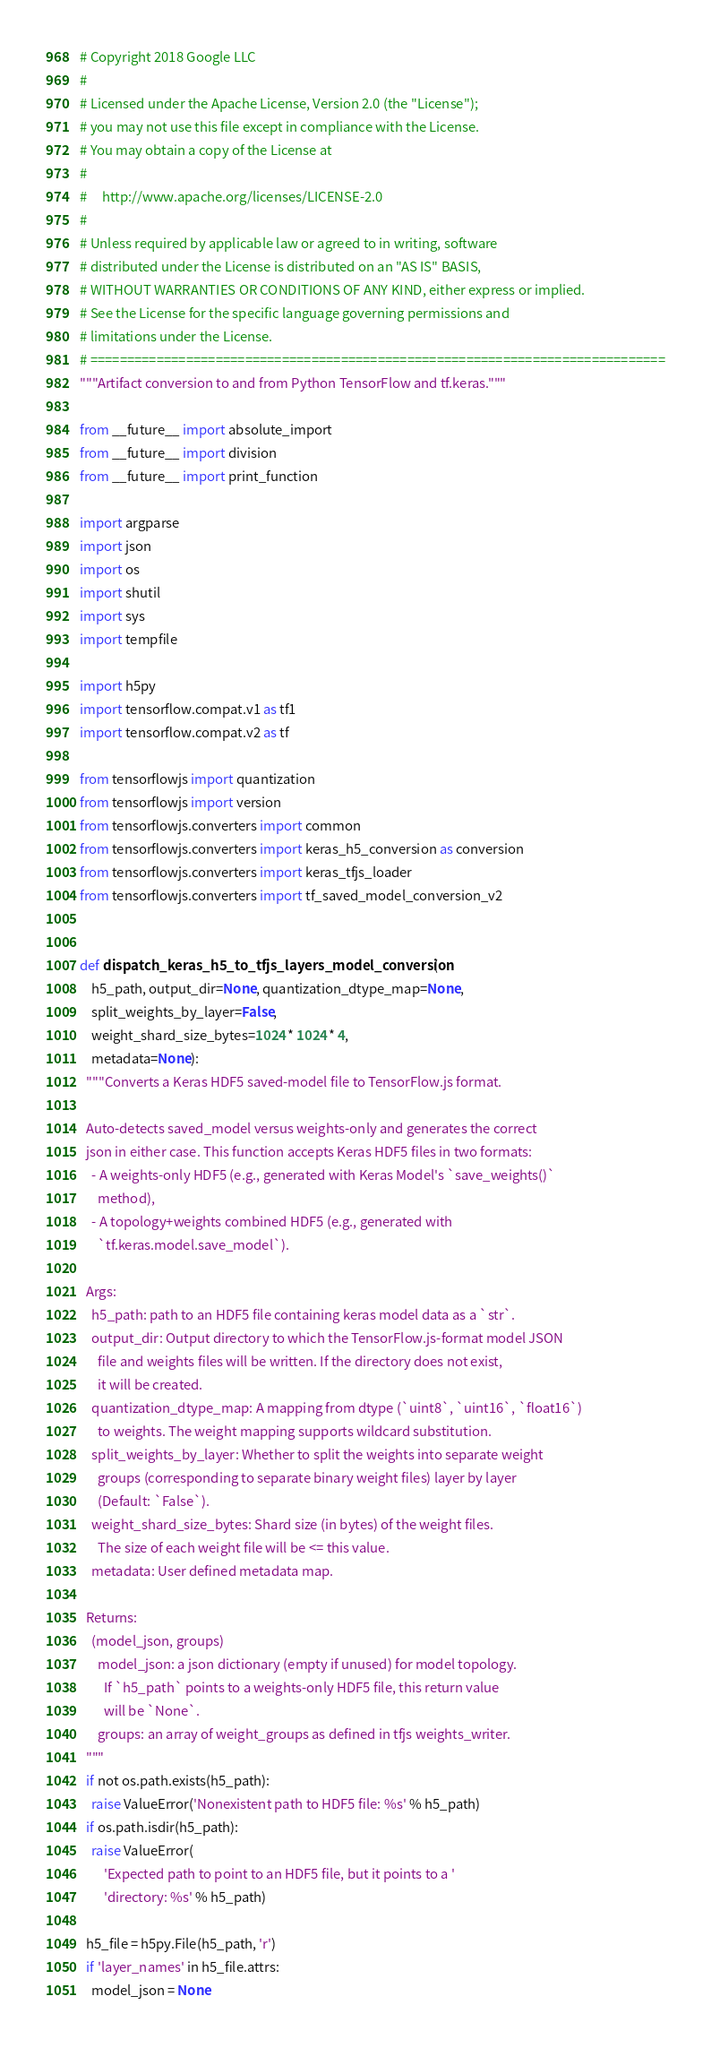<code> <loc_0><loc_0><loc_500><loc_500><_Python_># Copyright 2018 Google LLC
#
# Licensed under the Apache License, Version 2.0 (the "License");
# you may not use this file except in compliance with the License.
# You may obtain a copy of the License at
#
#     http://www.apache.org/licenses/LICENSE-2.0
#
# Unless required by applicable law or agreed to in writing, software
# distributed under the License is distributed on an "AS IS" BASIS,
# WITHOUT WARRANTIES OR CONDITIONS OF ANY KIND, either express or implied.
# See the License for the specific language governing permissions and
# limitations under the License.
# ==============================================================================
"""Artifact conversion to and from Python TensorFlow and tf.keras."""

from __future__ import absolute_import
from __future__ import division
from __future__ import print_function

import argparse
import json
import os
import shutil
import sys
import tempfile

import h5py
import tensorflow.compat.v1 as tf1
import tensorflow.compat.v2 as tf

from tensorflowjs import quantization
from tensorflowjs import version
from tensorflowjs.converters import common
from tensorflowjs.converters import keras_h5_conversion as conversion
from tensorflowjs.converters import keras_tfjs_loader
from tensorflowjs.converters import tf_saved_model_conversion_v2


def dispatch_keras_h5_to_tfjs_layers_model_conversion(
    h5_path, output_dir=None, quantization_dtype_map=None,
    split_weights_by_layer=False,
    weight_shard_size_bytes=1024 * 1024 * 4,
    metadata=None):
  """Converts a Keras HDF5 saved-model file to TensorFlow.js format.

  Auto-detects saved_model versus weights-only and generates the correct
  json in either case. This function accepts Keras HDF5 files in two formats:
    - A weights-only HDF5 (e.g., generated with Keras Model's `save_weights()`
      method),
    - A topology+weights combined HDF5 (e.g., generated with
      `tf.keras.model.save_model`).

  Args:
    h5_path: path to an HDF5 file containing keras model data as a `str`.
    output_dir: Output directory to which the TensorFlow.js-format model JSON
      file and weights files will be written. If the directory does not exist,
      it will be created.
    quantization_dtype_map: A mapping from dtype (`uint8`, `uint16`, `float16`)
      to weights. The weight mapping supports wildcard substitution.
    split_weights_by_layer: Whether to split the weights into separate weight
      groups (corresponding to separate binary weight files) layer by layer
      (Default: `False`).
    weight_shard_size_bytes: Shard size (in bytes) of the weight files.
      The size of each weight file will be <= this value.
    metadata: User defined metadata map.

  Returns:
    (model_json, groups)
      model_json: a json dictionary (empty if unused) for model topology.
        If `h5_path` points to a weights-only HDF5 file, this return value
        will be `None`.
      groups: an array of weight_groups as defined in tfjs weights_writer.
  """
  if not os.path.exists(h5_path):
    raise ValueError('Nonexistent path to HDF5 file: %s' % h5_path)
  if os.path.isdir(h5_path):
    raise ValueError(
        'Expected path to point to an HDF5 file, but it points to a '
        'directory: %s' % h5_path)

  h5_file = h5py.File(h5_path, 'r')
  if 'layer_names' in h5_file.attrs:
    model_json = None</code> 